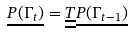Convert formula to latex. <formula><loc_0><loc_0><loc_500><loc_500>\underline { P ( \Gamma _ { t } ) } = \underline { \underline { T } } \underline { P ( \Gamma _ { t - 1 } ) }</formula> 